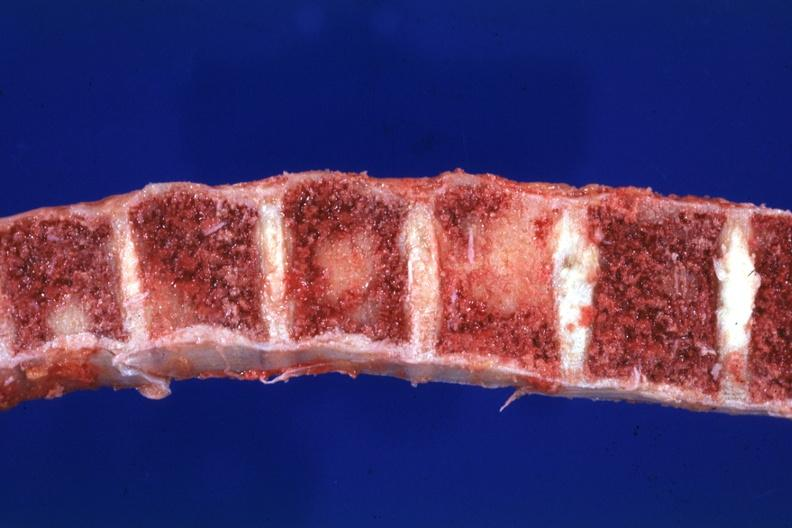what is present?
Answer the question using a single word or phrase. Joints 